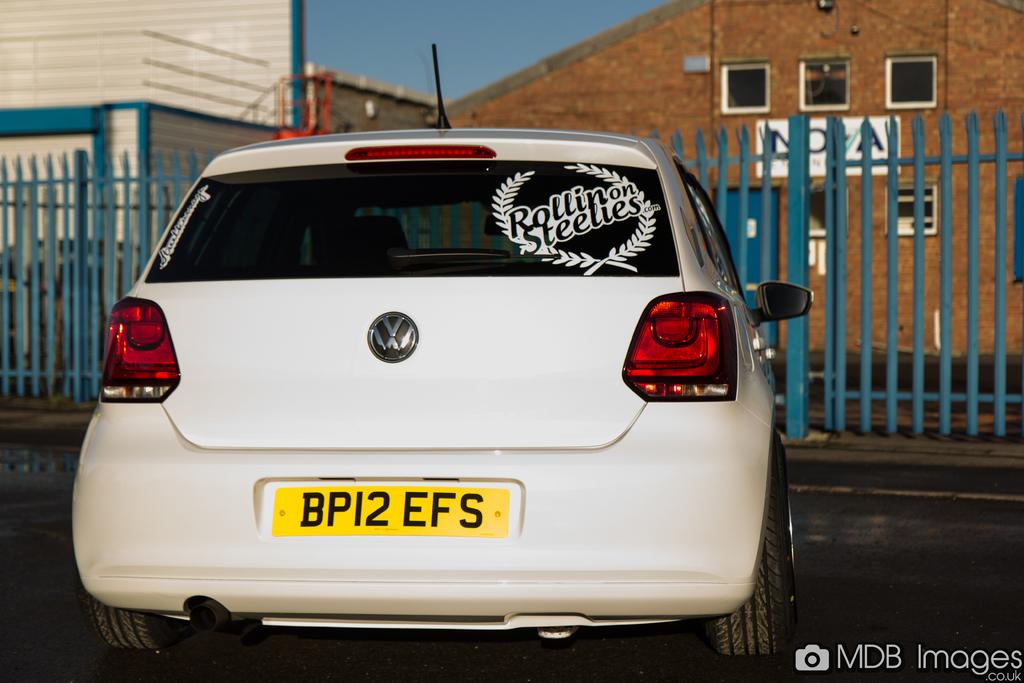What is the plate number?
Your response must be concise. Bp12 efs. What is on the window sticker?
Your response must be concise. Rollin on steelies. 